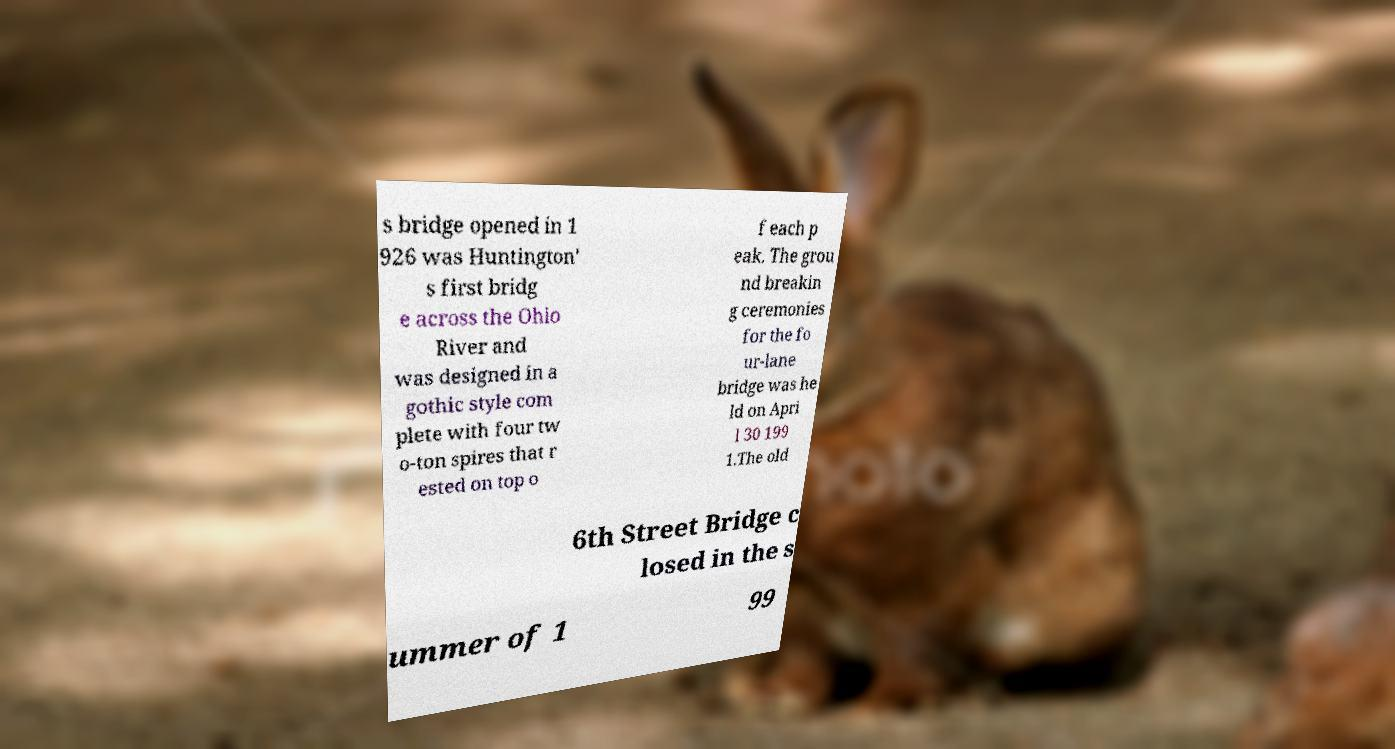Can you accurately transcribe the text from the provided image for me? s bridge opened in 1 926 was Huntington' s first bridg e across the Ohio River and was designed in a gothic style com plete with four tw o-ton spires that r ested on top o f each p eak. The grou nd breakin g ceremonies for the fo ur-lane bridge was he ld on Apri l 30 199 1.The old 6th Street Bridge c losed in the s ummer of 1 99 